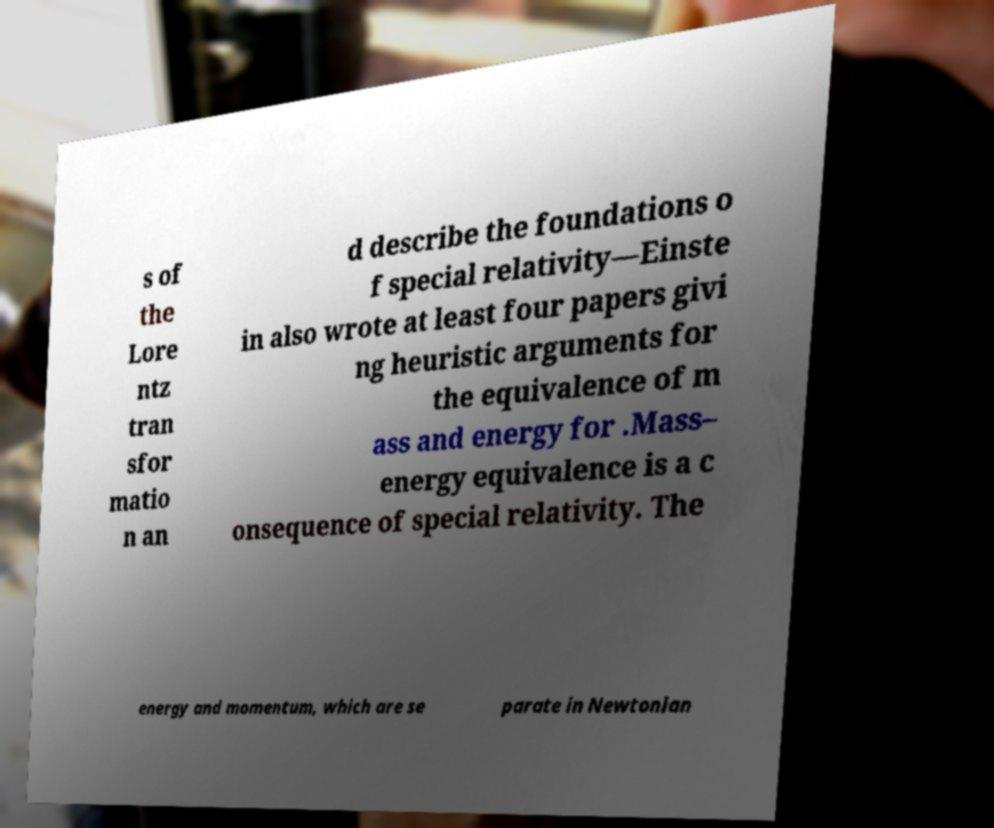Can you read and provide the text displayed in the image?This photo seems to have some interesting text. Can you extract and type it out for me? s of the Lore ntz tran sfor matio n an d describe the foundations o f special relativity—Einste in also wrote at least four papers givi ng heuristic arguments for the equivalence of m ass and energy for .Mass– energy equivalence is a c onsequence of special relativity. The energy and momentum, which are se parate in Newtonian 